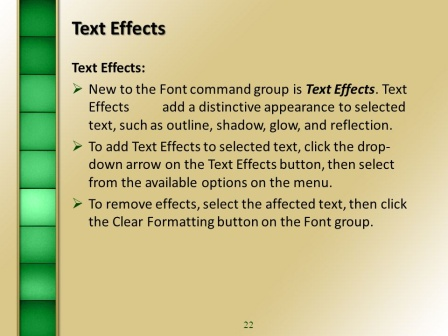Can you explain the purpose of the gradient bar on the left side of the slide? The gradient bar on the left side of the slide serves both an aesthetic and functional purpose. Visually, the gradient adds depth and a sense of movement to the slide, making the overall design more dynamic and engaging. It helps to create a balanced layout by providing a solid color element that contrasts with the text-heavy right side. Functionally, such design elements can help in visually segmenting the slide, guiding the viewer's eye from one part of the slide to another, and maintaining their engagement throughout the presentation. Why do you think the slide is numbered '22'? The slide is numbered '22' likely because it is part of a larger, well-organized presentation. Numbering slides helps both the presenter and the audience keep track of the content's sequence, especially in extensive presentations. It allows for easy referencing, enhancing clarity and structure during the presentation. 